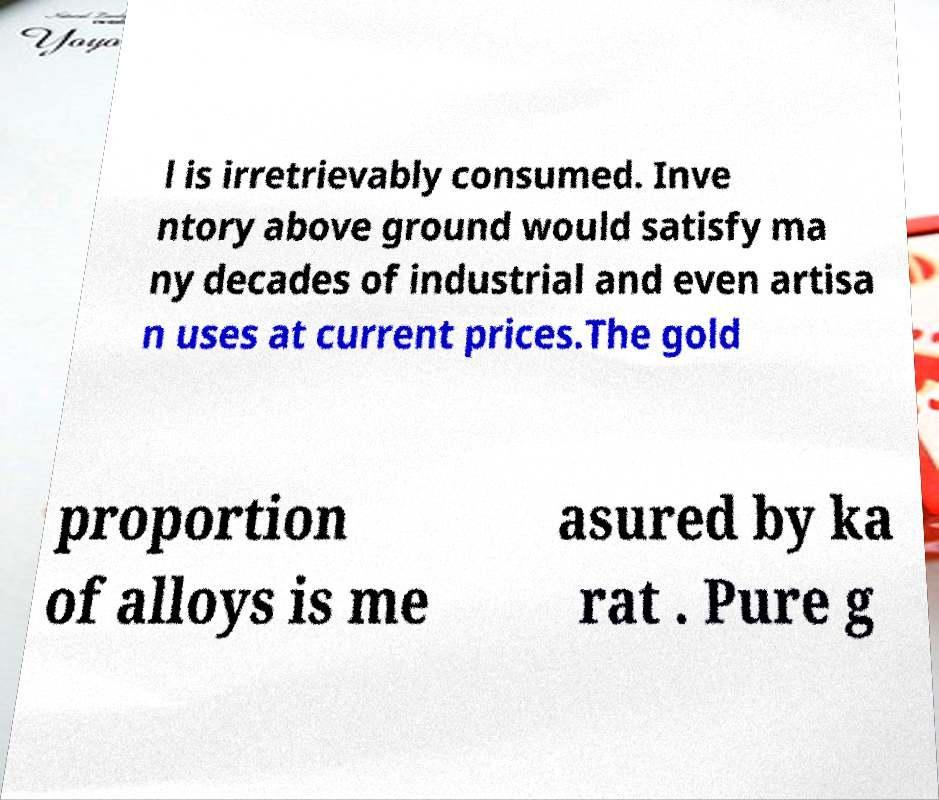Can you accurately transcribe the text from the provided image for me? l is irretrievably consumed. Inve ntory above ground would satisfy ma ny decades of industrial and even artisa n uses at current prices.The gold proportion of alloys is me asured by ka rat . Pure g 